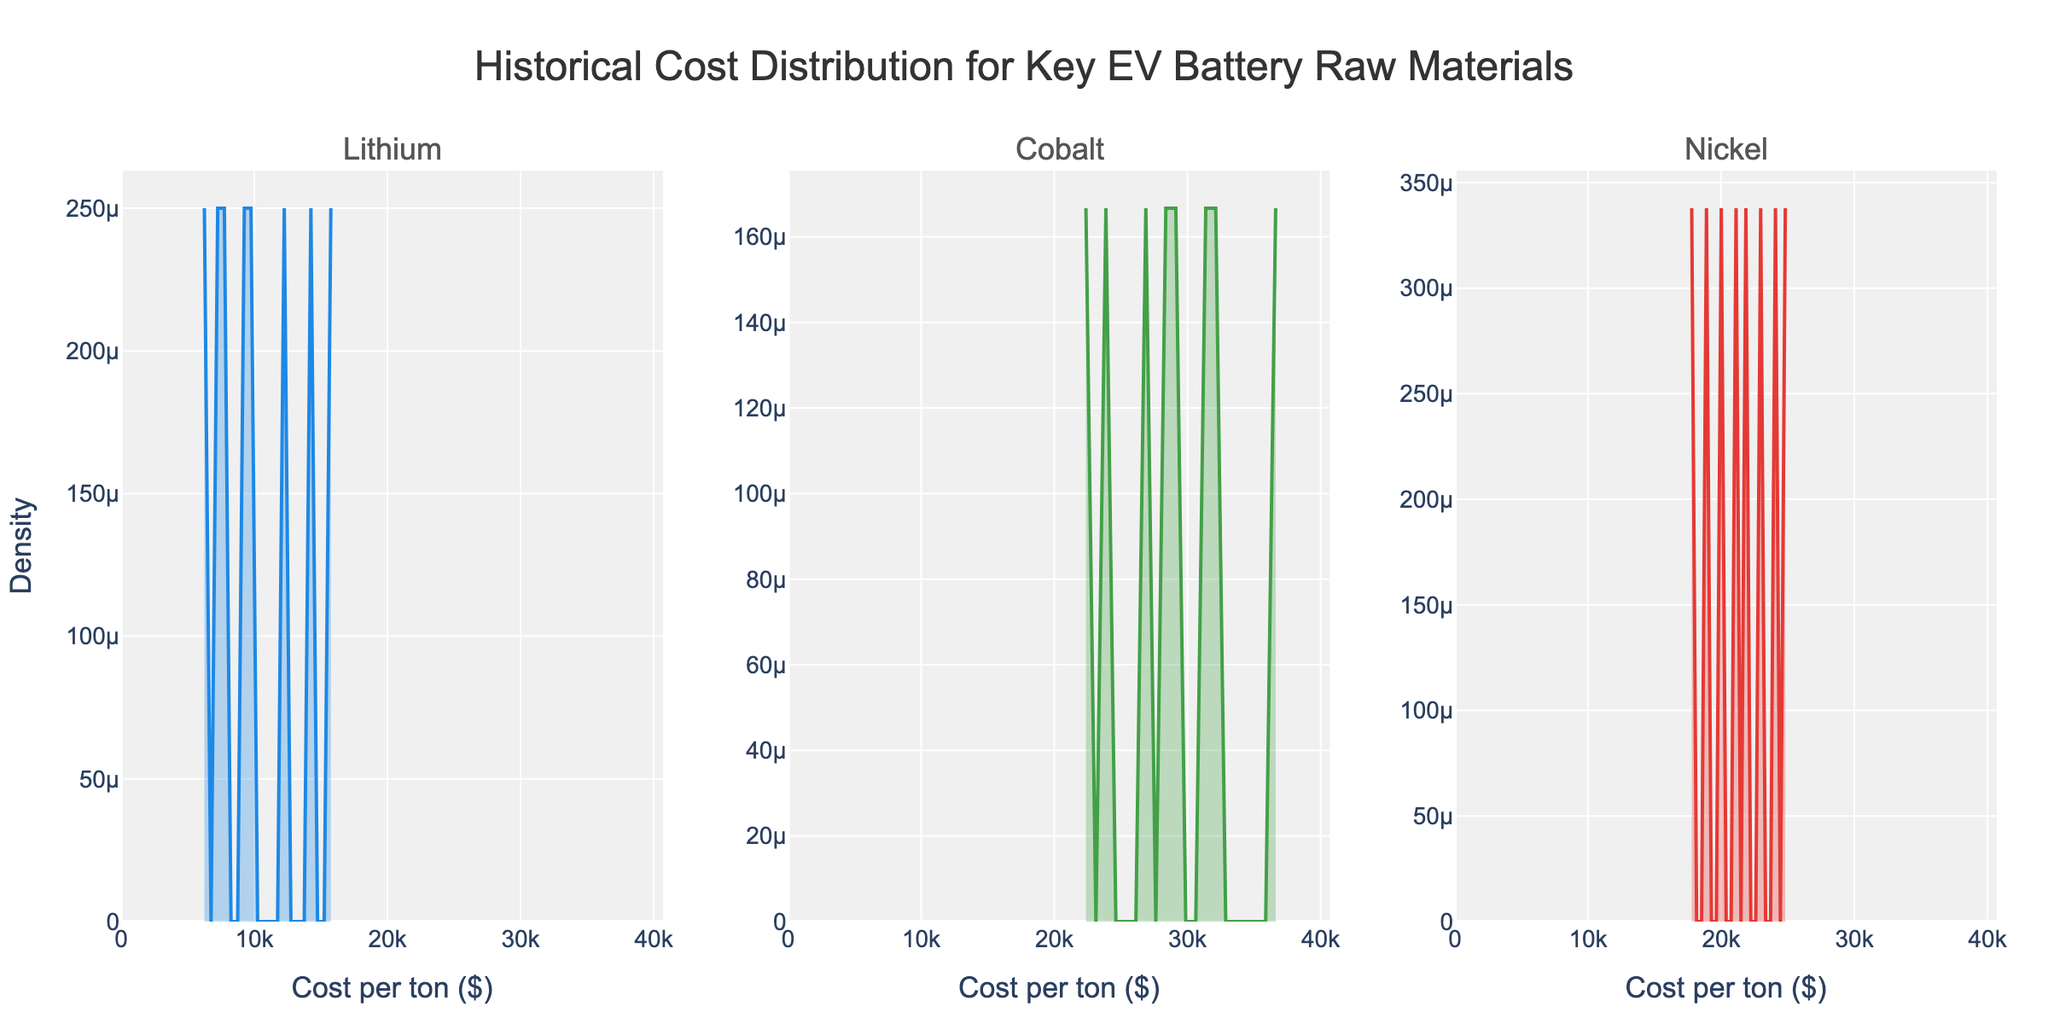What is the title of the figure? The title is displayed at the top of the plot, it reads: 'Historical Cost Distribution for Key EV Battery Raw Materials'.
Answer: Historical Cost Distribution for Key EV Battery Raw Materials How many subplots are there in the figure? The figure is divided into three separate plots, each representing a different raw material: Lithium, Cobalt, and Nickel.
Answer: Three Which raw material has the highest density peak in the figure? By observing the peaks of all the density plots, Cobalt's plot shows the highest density peak.
Answer: Cobalt What's the range of the x-axis for the subplot of Nickel? The x-axis range for Nickel can be found below the Nickel subplot and spans from $0 to $35200 considering the given range with a 1.1 multiplier of the max cost in the dataset.
Answer: $0 to $35200 Between Lithium and Nickel, which one shows a wider spread in cost distribution? Comparing the density curves of Lithium and Nickel, Nickel shows a broader distribution as its density curve is more spread out.
Answer: Nickel What is the color used for the Lithium density plot? The Lithium density plot is represented in blue, as observed from the color of the plot.
Answer: Blue Which raw material's density plot shows the least variation in cost? Comparing the plots, Lithium's cost distribution has the least variation as its density curve is taller and narrower compared to the other materials.
Answer: Lithium How does the cost distribution of Cobalt vary compared to that of Lithium? Cobalt’s distribution has a wider spread with multiple peaks, indicating a greater variation in costs over the years compared to the more consistent distribution of Lithium.
Answer: Greater variation What can be inferred about the historical cost trend of Nickel from its density plot? From the wide spread and multiple density peaks in Nickel’s plot, we infer that Nickel's cost has fluctuated significantly over the observed years.
Answer: Significant fluctuation 